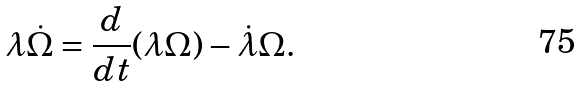Convert formula to latex. <formula><loc_0><loc_0><loc_500><loc_500>\lambda \dot { \Omega } = \frac { d } { d t } ( \lambda \Omega ) - \dot { \lambda } \Omega .</formula> 